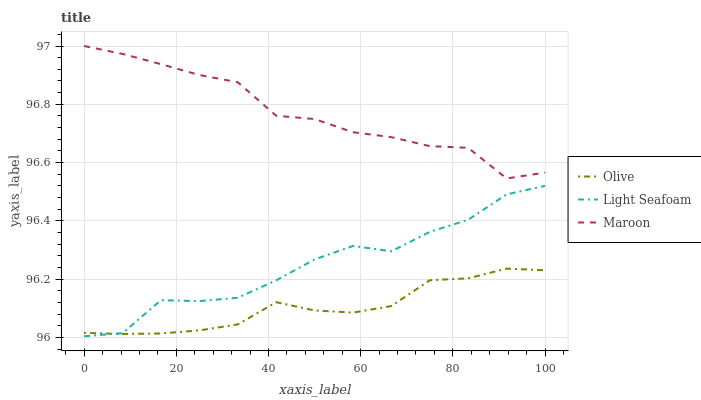Does Olive have the minimum area under the curve?
Answer yes or no. Yes. Does Maroon have the maximum area under the curve?
Answer yes or no. Yes. Does Light Seafoam have the minimum area under the curve?
Answer yes or no. No. Does Light Seafoam have the maximum area under the curve?
Answer yes or no. No. Is Olive the smoothest?
Answer yes or no. Yes. Is Light Seafoam the roughest?
Answer yes or no. Yes. Is Maroon the smoothest?
Answer yes or no. No. Is Maroon the roughest?
Answer yes or no. No. Does Light Seafoam have the lowest value?
Answer yes or no. Yes. Does Maroon have the lowest value?
Answer yes or no. No. Does Maroon have the highest value?
Answer yes or no. Yes. Does Light Seafoam have the highest value?
Answer yes or no. No. Is Light Seafoam less than Maroon?
Answer yes or no. Yes. Is Maroon greater than Light Seafoam?
Answer yes or no. Yes. Does Olive intersect Light Seafoam?
Answer yes or no. Yes. Is Olive less than Light Seafoam?
Answer yes or no. No. Is Olive greater than Light Seafoam?
Answer yes or no. No. Does Light Seafoam intersect Maroon?
Answer yes or no. No. 